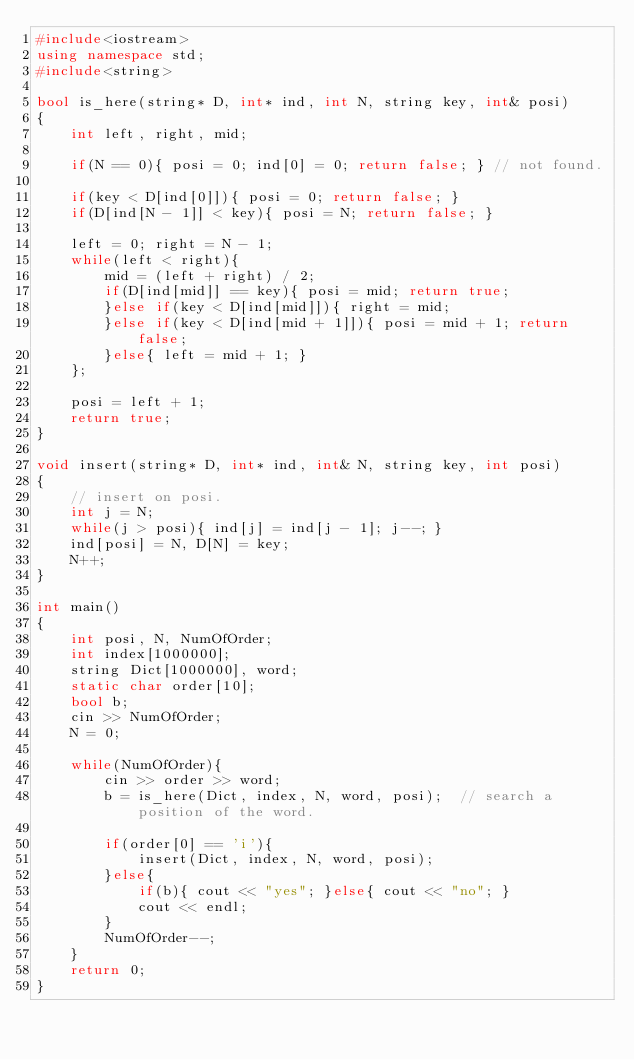Convert code to text. <code><loc_0><loc_0><loc_500><loc_500><_C++_>#include<iostream>
using namespace std;
#include<string>

bool is_here(string* D, int* ind, int N, string key, int& posi)
{
    int left, right, mid;

    if(N == 0){ posi = 0; ind[0] = 0; return false; } // not found.

    if(key < D[ind[0]]){ posi = 0; return false; }
    if(D[ind[N - 1]] < key){ posi = N; return false; }

    left = 0; right = N - 1;
    while(left < right){
        mid = (left + right) / 2;
        if(D[ind[mid]] == key){ posi = mid; return true;
        }else if(key < D[ind[mid]]){ right = mid;
        }else if(key < D[ind[mid + 1]]){ posi = mid + 1; return false;
		}else{ left = mid + 1; }
    };

    posi = left + 1;
    return true;
}

void insert(string* D, int* ind, int& N, string key, int posi)
{
    // insert on posi.
    int j = N;
    while(j > posi){ ind[j] = ind[j - 1]; j--; }
    ind[posi] = N, D[N] = key;
    N++;
}

int main()
{
    int posi, N, NumOfOrder;
    int index[1000000];
    string Dict[1000000], word;
    static char order[10];
    bool b;
    cin >> NumOfOrder;
    N = 0;

    while(NumOfOrder){
        cin >> order >> word;
        b = is_here(Dict, index, N, word, posi);  // search a position of the word.

        if(order[0] == 'i'){
            insert(Dict, index, N, word, posi);
        }else{
            if(b){ cout << "yes"; }else{ cout << "no"; }
            cout << endl;
        }
        NumOfOrder--;
    }
    return 0;
}</code> 